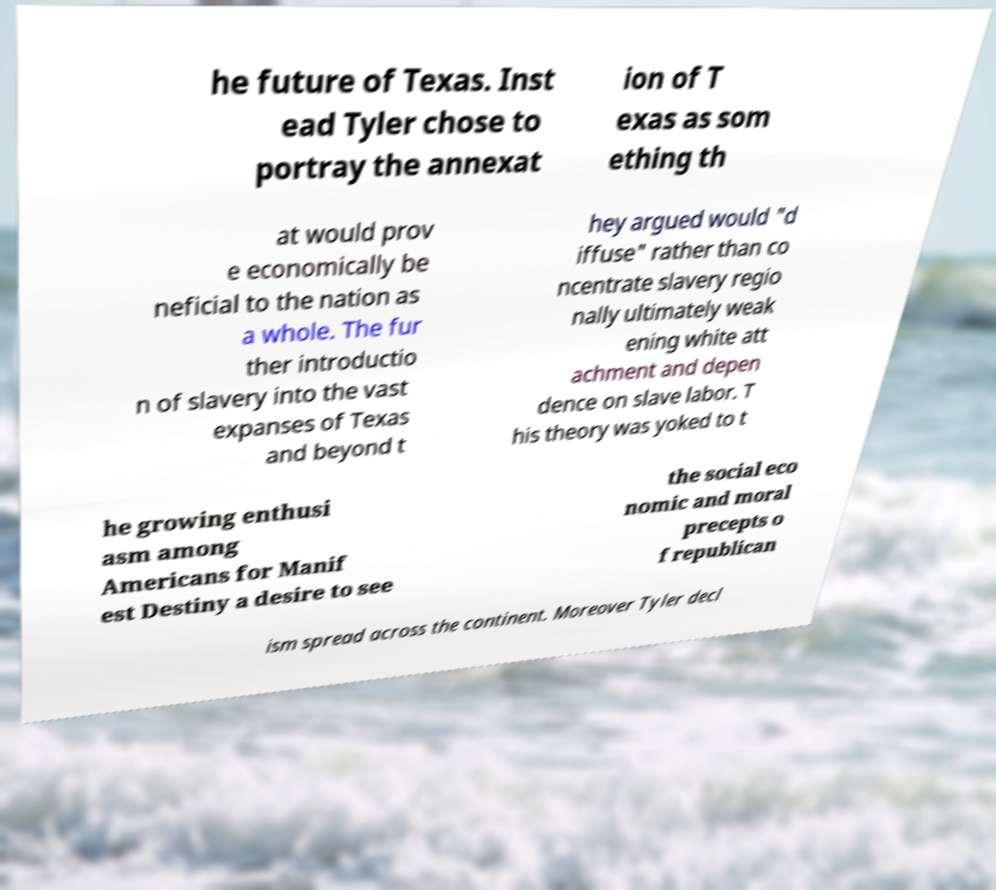There's text embedded in this image that I need extracted. Can you transcribe it verbatim? he future of Texas. Inst ead Tyler chose to portray the annexat ion of T exas as som ething th at would prov e economically be neficial to the nation as a whole. The fur ther introductio n of slavery into the vast expanses of Texas and beyond t hey argued would "d iffuse" rather than co ncentrate slavery regio nally ultimately weak ening white att achment and depen dence on slave labor. T his theory was yoked to t he growing enthusi asm among Americans for Manif est Destiny a desire to see the social eco nomic and moral precepts o f republican ism spread across the continent. Moreover Tyler decl 